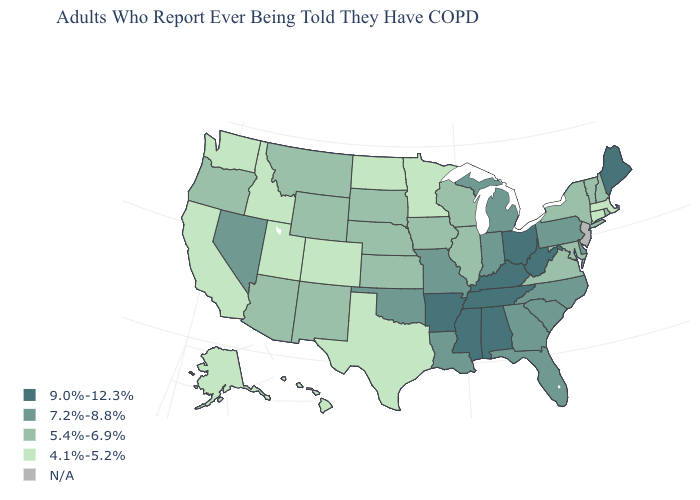Name the states that have a value in the range 5.4%-6.9%?
Quick response, please. Arizona, Illinois, Iowa, Kansas, Maryland, Montana, Nebraska, New Hampshire, New Mexico, New York, Oregon, Rhode Island, South Dakota, Vermont, Virginia, Wisconsin, Wyoming. Name the states that have a value in the range 5.4%-6.9%?
Write a very short answer. Arizona, Illinois, Iowa, Kansas, Maryland, Montana, Nebraska, New Hampshire, New Mexico, New York, Oregon, Rhode Island, South Dakota, Vermont, Virginia, Wisconsin, Wyoming. Which states hav the highest value in the Northeast?
Keep it brief. Maine. Name the states that have a value in the range 7.2%-8.8%?
Be succinct. Delaware, Florida, Georgia, Indiana, Louisiana, Michigan, Missouri, Nevada, North Carolina, Oklahoma, Pennsylvania, South Carolina. What is the value of Tennessee?
Write a very short answer. 9.0%-12.3%. Does Iowa have the highest value in the MidWest?
Keep it brief. No. What is the value of New Hampshire?
Give a very brief answer. 5.4%-6.9%. Name the states that have a value in the range N/A?
Keep it brief. New Jersey. Name the states that have a value in the range 9.0%-12.3%?
Be succinct. Alabama, Arkansas, Kentucky, Maine, Mississippi, Ohio, Tennessee, West Virginia. What is the value of New Jersey?
Keep it brief. N/A. What is the highest value in the USA?
Be succinct. 9.0%-12.3%. What is the value of Arkansas?
Concise answer only. 9.0%-12.3%. What is the value of Maine?
Short answer required. 9.0%-12.3%. What is the value of Connecticut?
Concise answer only. 4.1%-5.2%. Does Georgia have the lowest value in the USA?
Write a very short answer. No. 